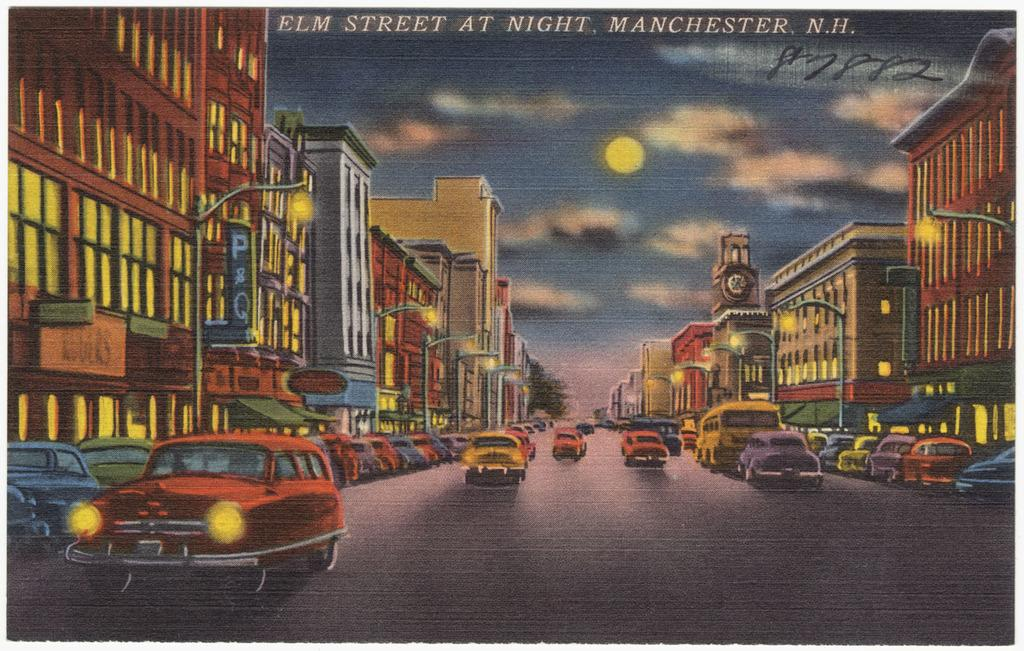<image>
Share a concise interpretation of the image provided. A postcard picture of a street with lots of cars and buildings at night and it says the top Elm Street at Night Manchester N.H. 